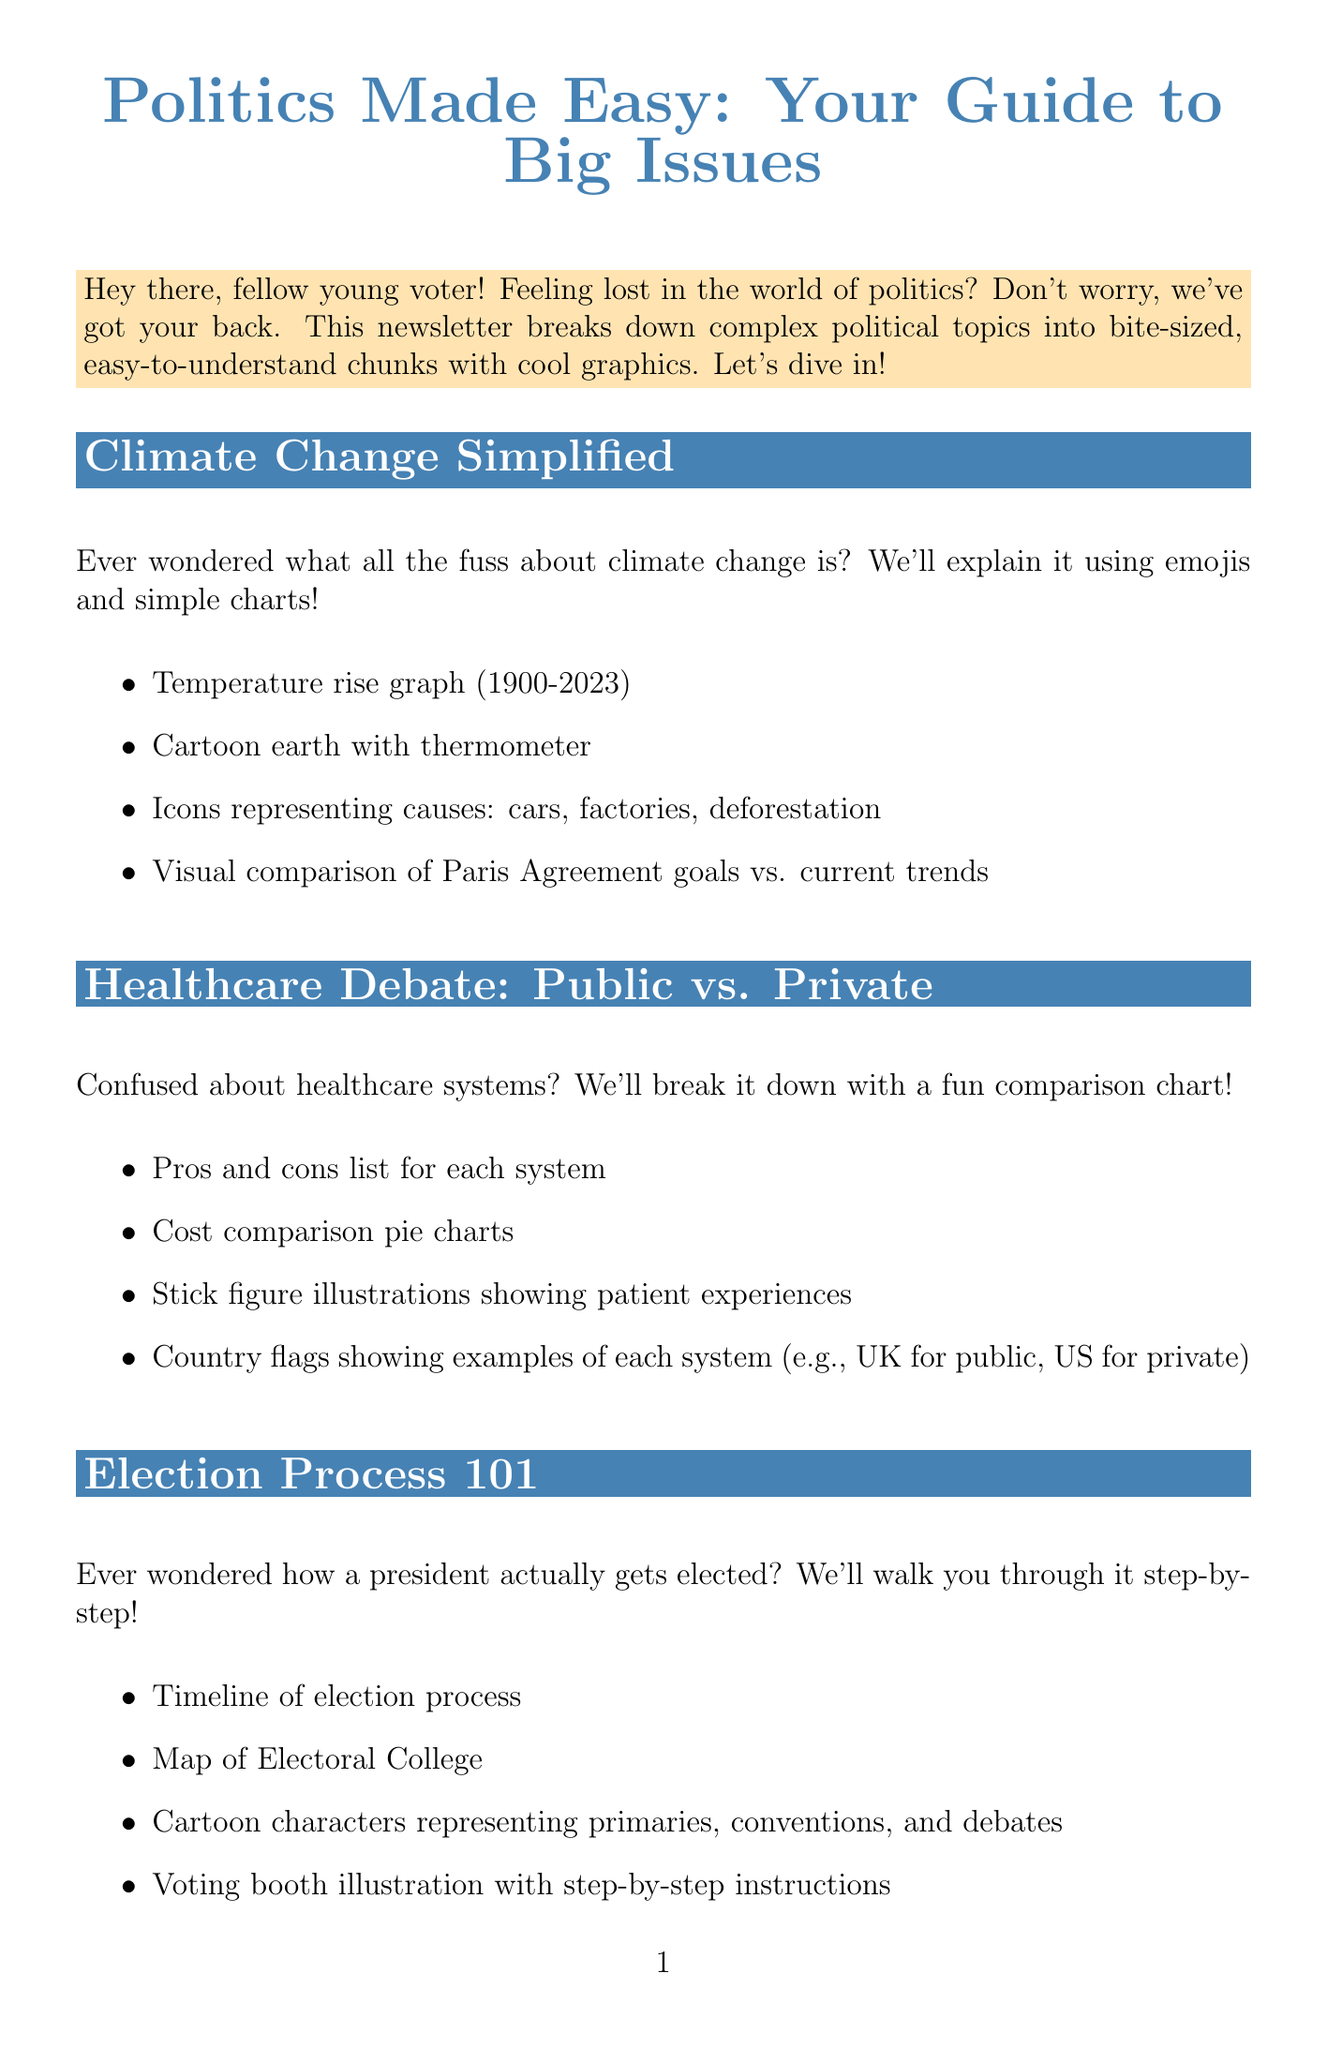What is the title of the newsletter? The title of the newsletter is mentioned at the beginning of the document.
Answer: Politics Made Easy: Your Guide to Big Issues What is one element used in the Climate Change section? The Climate Change section lists various infographic elements that will be included.
Answer: Temperature rise graph (1900-2023) Which healthcare system is represented by the UK flag? The document provides information about healthcare systems and their examples using country flags.
Answer: Public What interactive element is offered in the newsletter? The interactive element is described in the newsletter as a quiz to gauge political alignment.
Answer: Political Party Quiz What is one action item to get involved? The newsletter includes several suggestions on getting started with involvement in politics.
Answer: Register to vote online at Vote.gov What type of chart is included in the Healthcare Debate section? The Healthcare Debate section references specific infographic elements including comparisons.
Answer: Cost comparison pie charts How many main sections are there in the newsletter? The main sections of the newsletter are explicitly listed in the document.
Answer: Three What is the closing statement in the newsletter? The closing statement serves to summarize the newsletter's message.
Answer: Remember, your vote matters! Stay informed, stay engaged, and let's shape the future together 